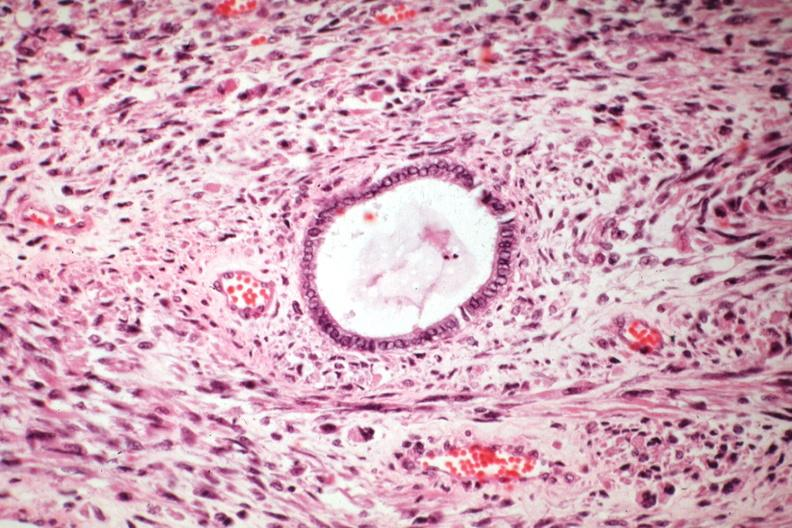s inflamed exocervix present?
Answer the question using a single word or phrase. No 